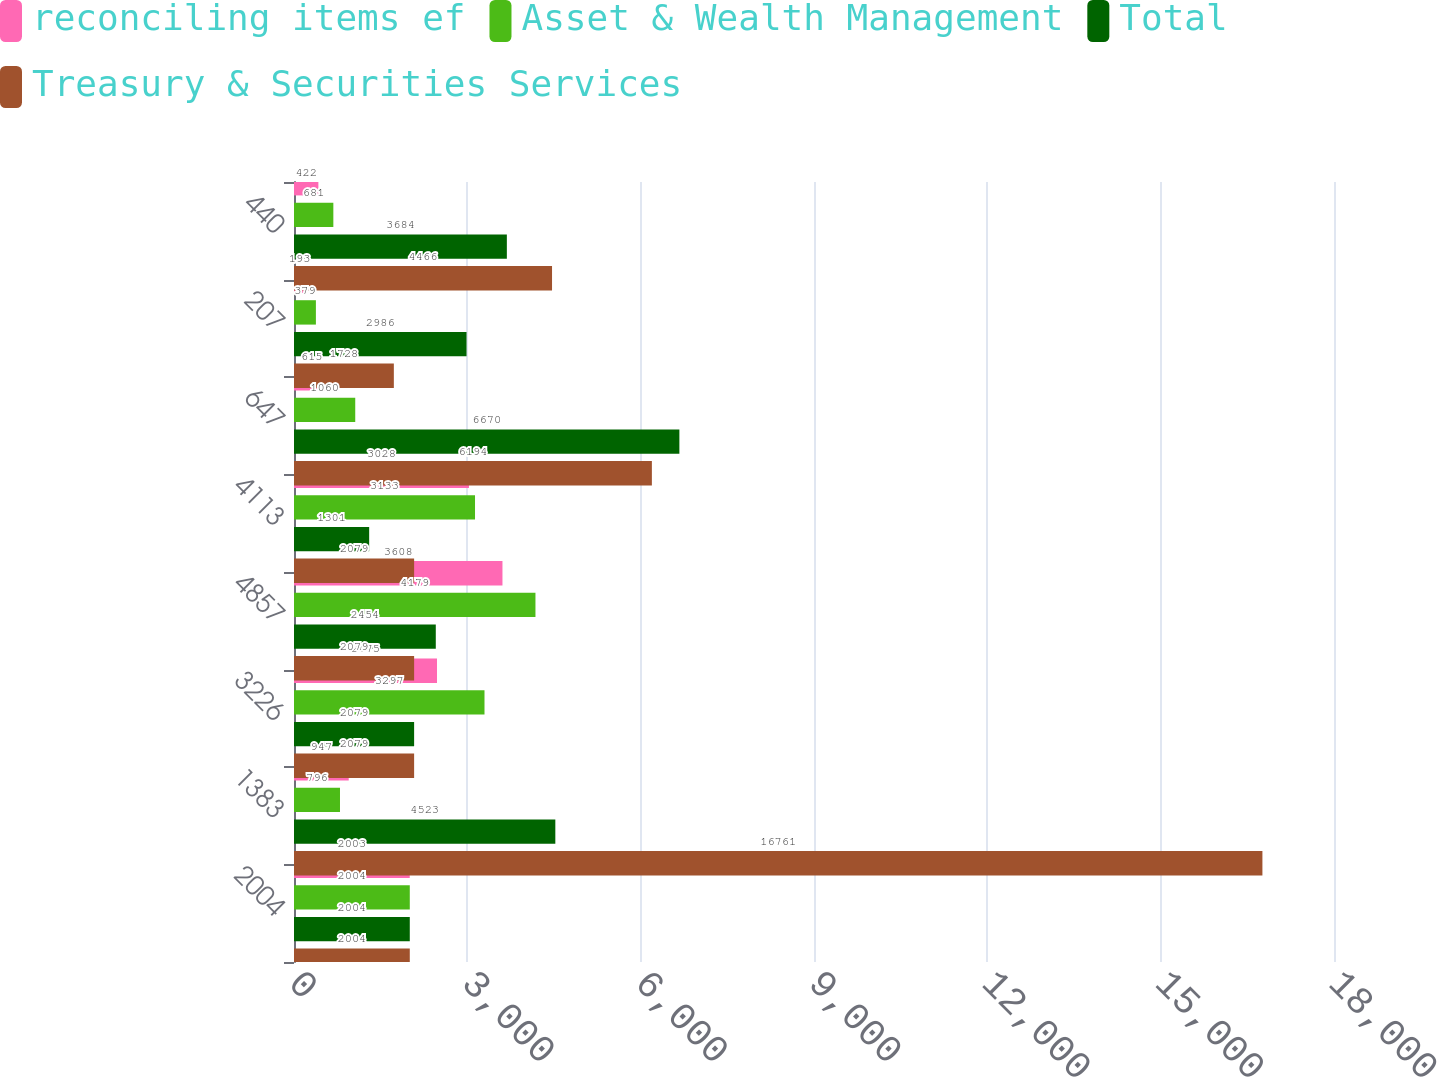Convert chart. <chart><loc_0><loc_0><loc_500><loc_500><stacked_bar_chart><ecel><fcel>2004<fcel>1383<fcel>3226<fcel>4857<fcel>4113<fcel>647<fcel>207<fcel>440<nl><fcel>reconciling items ef<fcel>2003<fcel>947<fcel>2475<fcel>3608<fcel>3028<fcel>615<fcel>193<fcel>422<nl><fcel>Asset & Wealth Management<fcel>2004<fcel>796<fcel>3297<fcel>4179<fcel>3133<fcel>1060<fcel>379<fcel>681<nl><fcel>Total<fcel>2004<fcel>4523<fcel>2079<fcel>2454<fcel>1301<fcel>6670<fcel>2986<fcel>3684<nl><fcel>Treasury & Securities Services<fcel>2004<fcel>16761<fcel>2079<fcel>2079<fcel>2079<fcel>6194<fcel>1728<fcel>4466<nl></chart> 